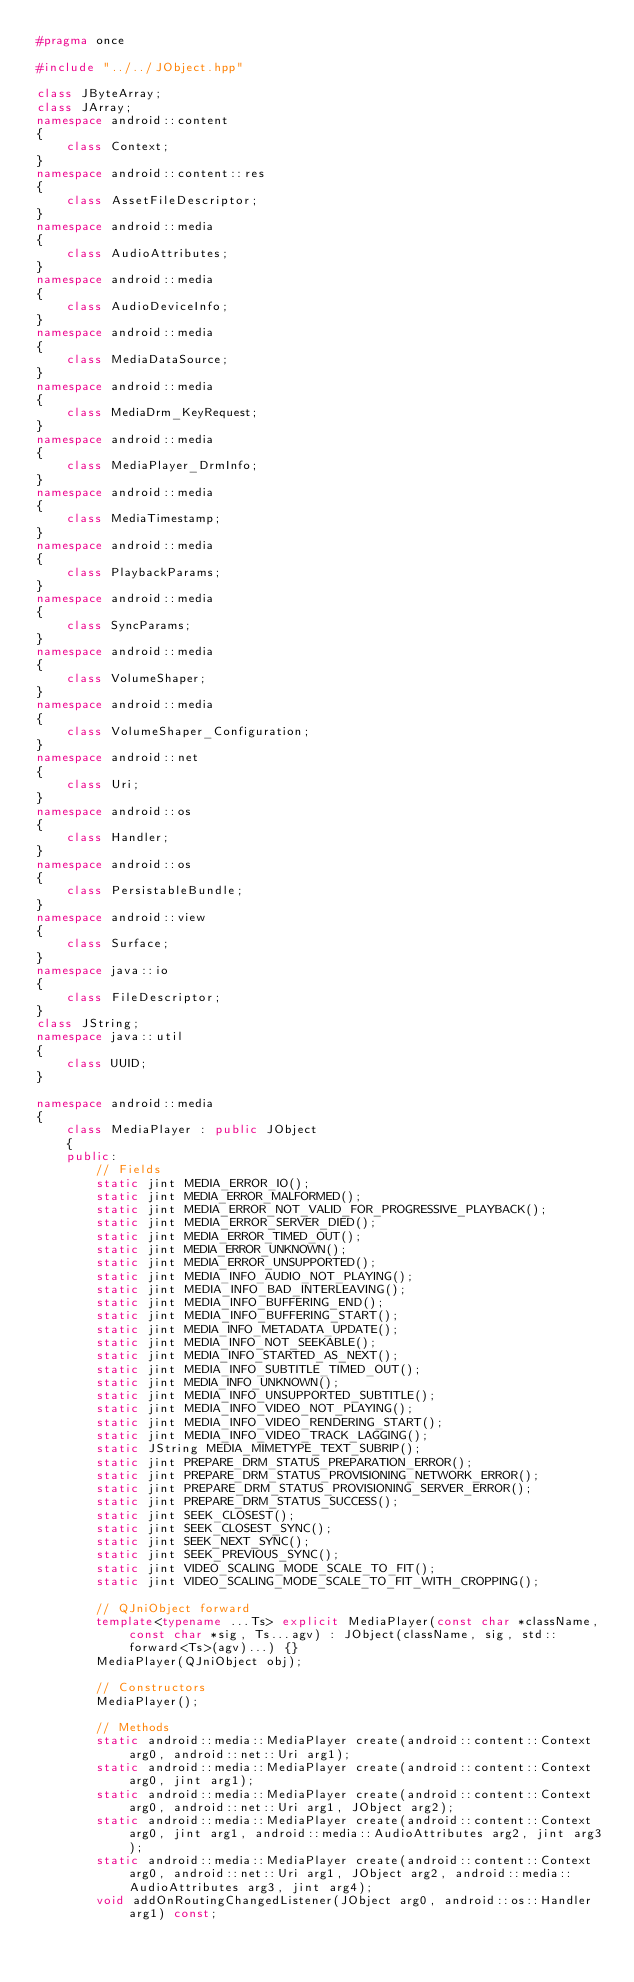<code> <loc_0><loc_0><loc_500><loc_500><_C++_>#pragma once

#include "../../JObject.hpp"

class JByteArray;
class JArray;
namespace android::content
{
	class Context;
}
namespace android::content::res
{
	class AssetFileDescriptor;
}
namespace android::media
{
	class AudioAttributes;
}
namespace android::media
{
	class AudioDeviceInfo;
}
namespace android::media
{
	class MediaDataSource;
}
namespace android::media
{
	class MediaDrm_KeyRequest;
}
namespace android::media
{
	class MediaPlayer_DrmInfo;
}
namespace android::media
{
	class MediaTimestamp;
}
namespace android::media
{
	class PlaybackParams;
}
namespace android::media
{
	class SyncParams;
}
namespace android::media
{
	class VolumeShaper;
}
namespace android::media
{
	class VolumeShaper_Configuration;
}
namespace android::net
{
	class Uri;
}
namespace android::os
{
	class Handler;
}
namespace android::os
{
	class PersistableBundle;
}
namespace android::view
{
	class Surface;
}
namespace java::io
{
	class FileDescriptor;
}
class JString;
namespace java::util
{
	class UUID;
}

namespace android::media
{
	class MediaPlayer : public JObject
	{
	public:
		// Fields
		static jint MEDIA_ERROR_IO();
		static jint MEDIA_ERROR_MALFORMED();
		static jint MEDIA_ERROR_NOT_VALID_FOR_PROGRESSIVE_PLAYBACK();
		static jint MEDIA_ERROR_SERVER_DIED();
		static jint MEDIA_ERROR_TIMED_OUT();
		static jint MEDIA_ERROR_UNKNOWN();
		static jint MEDIA_ERROR_UNSUPPORTED();
		static jint MEDIA_INFO_AUDIO_NOT_PLAYING();
		static jint MEDIA_INFO_BAD_INTERLEAVING();
		static jint MEDIA_INFO_BUFFERING_END();
		static jint MEDIA_INFO_BUFFERING_START();
		static jint MEDIA_INFO_METADATA_UPDATE();
		static jint MEDIA_INFO_NOT_SEEKABLE();
		static jint MEDIA_INFO_STARTED_AS_NEXT();
		static jint MEDIA_INFO_SUBTITLE_TIMED_OUT();
		static jint MEDIA_INFO_UNKNOWN();
		static jint MEDIA_INFO_UNSUPPORTED_SUBTITLE();
		static jint MEDIA_INFO_VIDEO_NOT_PLAYING();
		static jint MEDIA_INFO_VIDEO_RENDERING_START();
		static jint MEDIA_INFO_VIDEO_TRACK_LAGGING();
		static JString MEDIA_MIMETYPE_TEXT_SUBRIP();
		static jint PREPARE_DRM_STATUS_PREPARATION_ERROR();
		static jint PREPARE_DRM_STATUS_PROVISIONING_NETWORK_ERROR();
		static jint PREPARE_DRM_STATUS_PROVISIONING_SERVER_ERROR();
		static jint PREPARE_DRM_STATUS_SUCCESS();
		static jint SEEK_CLOSEST();
		static jint SEEK_CLOSEST_SYNC();
		static jint SEEK_NEXT_SYNC();
		static jint SEEK_PREVIOUS_SYNC();
		static jint VIDEO_SCALING_MODE_SCALE_TO_FIT();
		static jint VIDEO_SCALING_MODE_SCALE_TO_FIT_WITH_CROPPING();
		
		// QJniObject forward
		template<typename ...Ts> explicit MediaPlayer(const char *className, const char *sig, Ts...agv) : JObject(className, sig, std::forward<Ts>(agv)...) {}
		MediaPlayer(QJniObject obj);
		
		// Constructors
		MediaPlayer();
		
		// Methods
		static android::media::MediaPlayer create(android::content::Context arg0, android::net::Uri arg1);
		static android::media::MediaPlayer create(android::content::Context arg0, jint arg1);
		static android::media::MediaPlayer create(android::content::Context arg0, android::net::Uri arg1, JObject arg2);
		static android::media::MediaPlayer create(android::content::Context arg0, jint arg1, android::media::AudioAttributes arg2, jint arg3);
		static android::media::MediaPlayer create(android::content::Context arg0, android::net::Uri arg1, JObject arg2, android::media::AudioAttributes arg3, jint arg4);
		void addOnRoutingChangedListener(JObject arg0, android::os::Handler arg1) const;</code> 